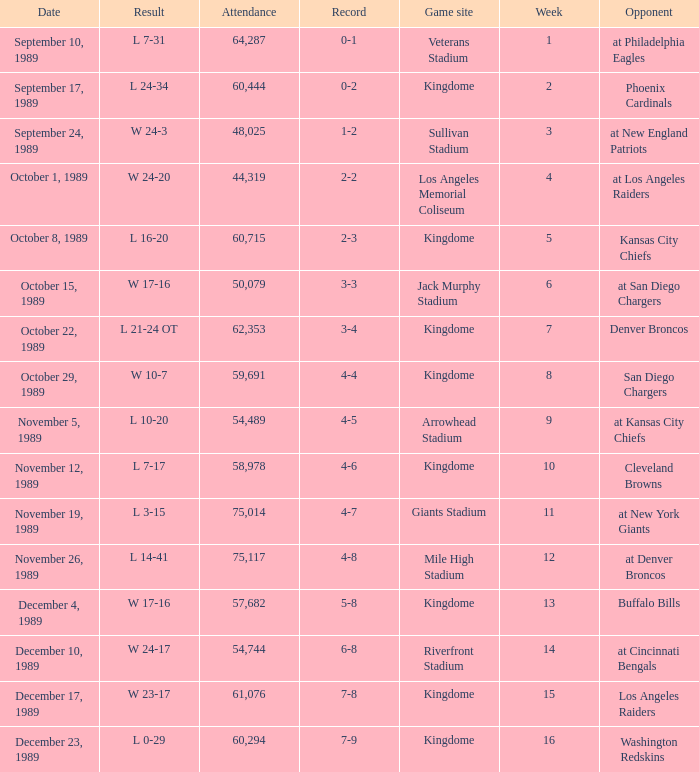Name the result for kingdome game site and opponent of denver broncos L 21-24 OT. 